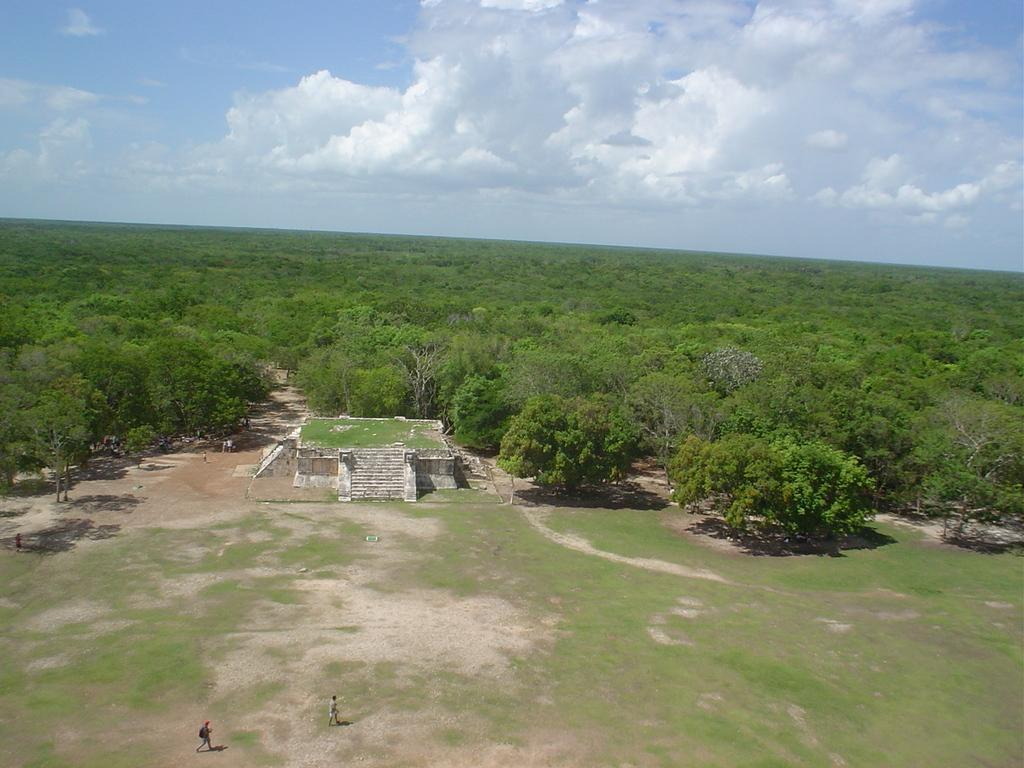What is the main subject of the image? There is a stone monument in the image. Where is the stone monument located? The stone monument is in the middle of a grassland. What can be seen behind the stone monument? There are trees behind the stone monument. What is visible in the sky in the image? The sky is visible in the image, and clouds are present. What type of skirt is hanging from the tree in the image? There is no skirt present in the image; it features a stone monument in a grassland with trees behind it and a sky with clouds. Can you see any sparks coming from the stone monument in the image? There are no sparks visible in the image; it shows a stationary stone monument in a grassland with trees and a sky with clouds. 